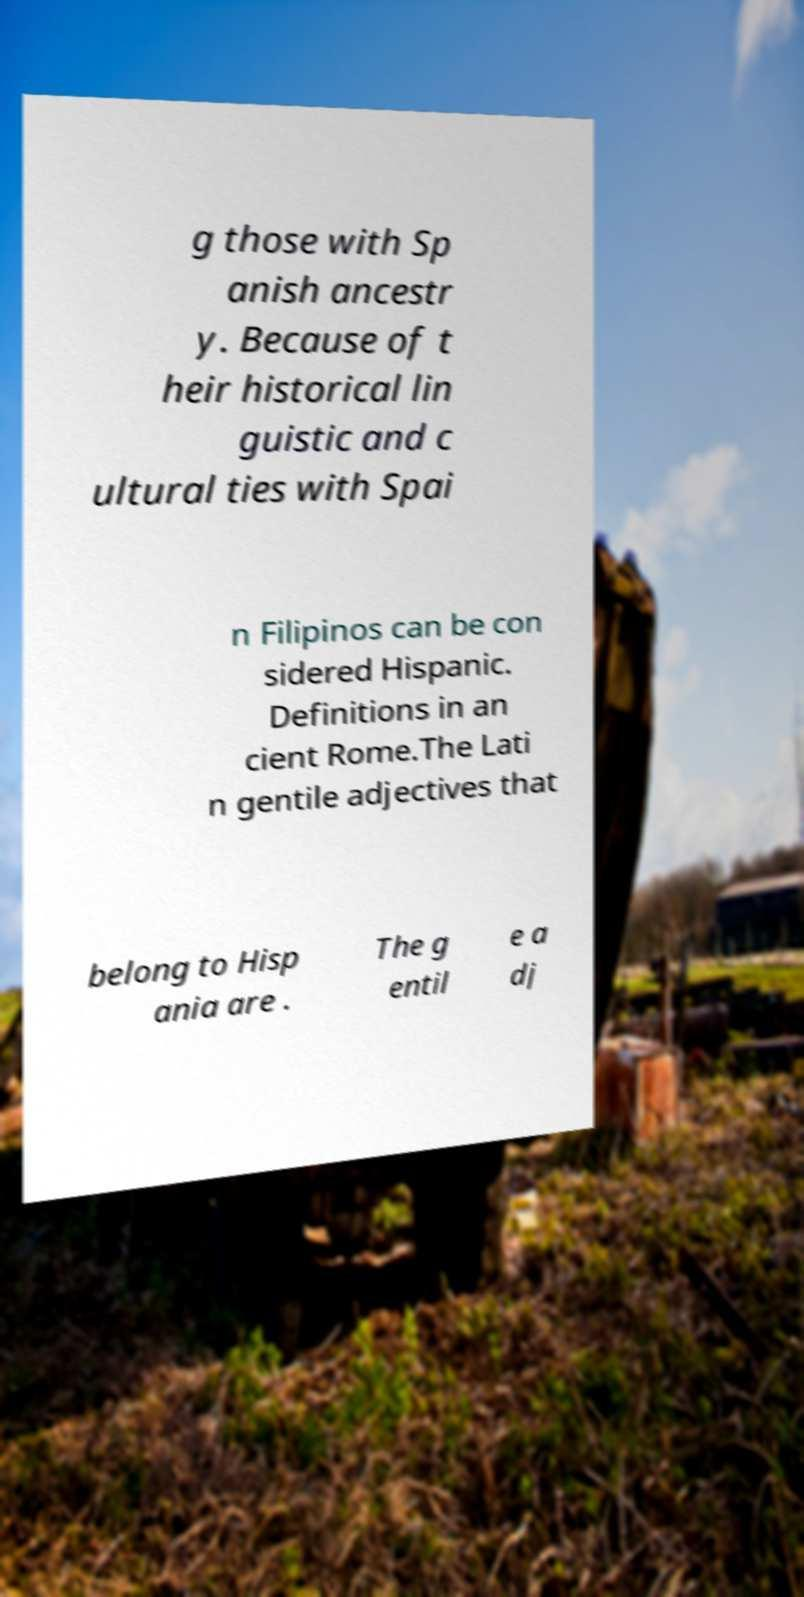Please identify and transcribe the text found in this image. g those with Sp anish ancestr y. Because of t heir historical lin guistic and c ultural ties with Spai n Filipinos can be con sidered Hispanic. Definitions in an cient Rome.The Lati n gentile adjectives that belong to Hisp ania are . The g entil e a dj 